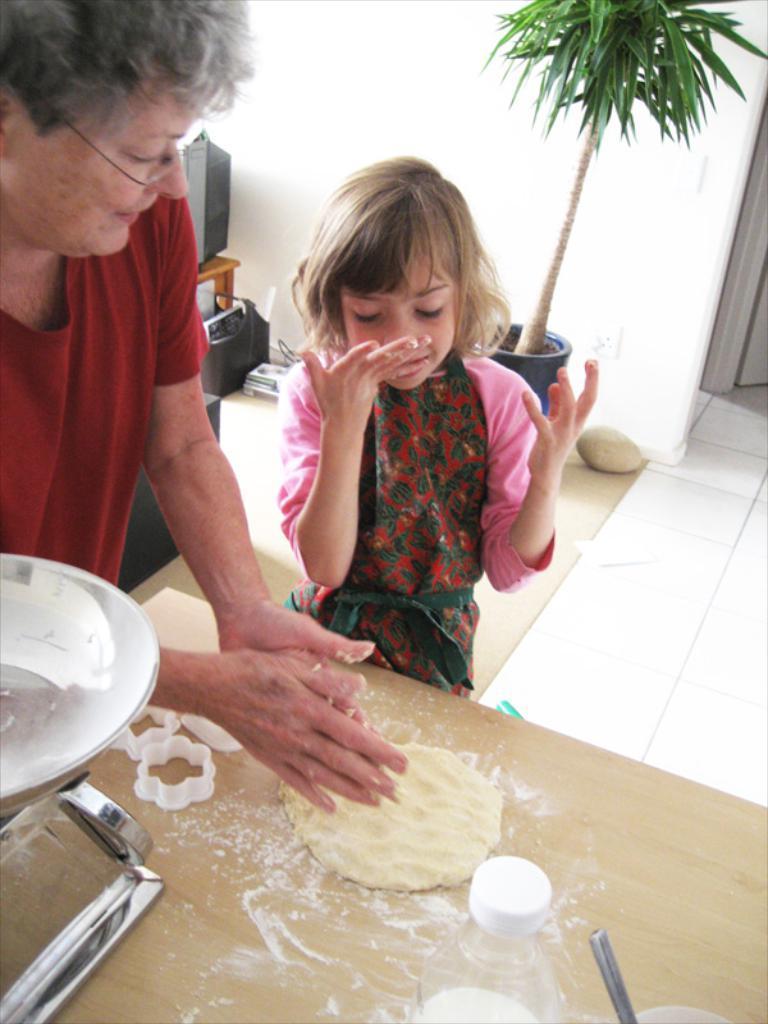Can you describe this image briefly? In this picture we can see a plant and two people in front of the plant and they are standing in front table on which there are some things. 